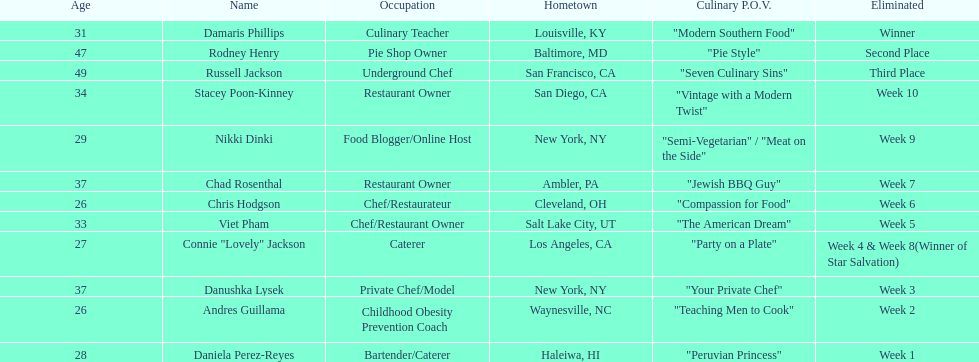Who was the first contestant to be eliminated on season 9 of food network star? Daniela Perez-Reyes. 